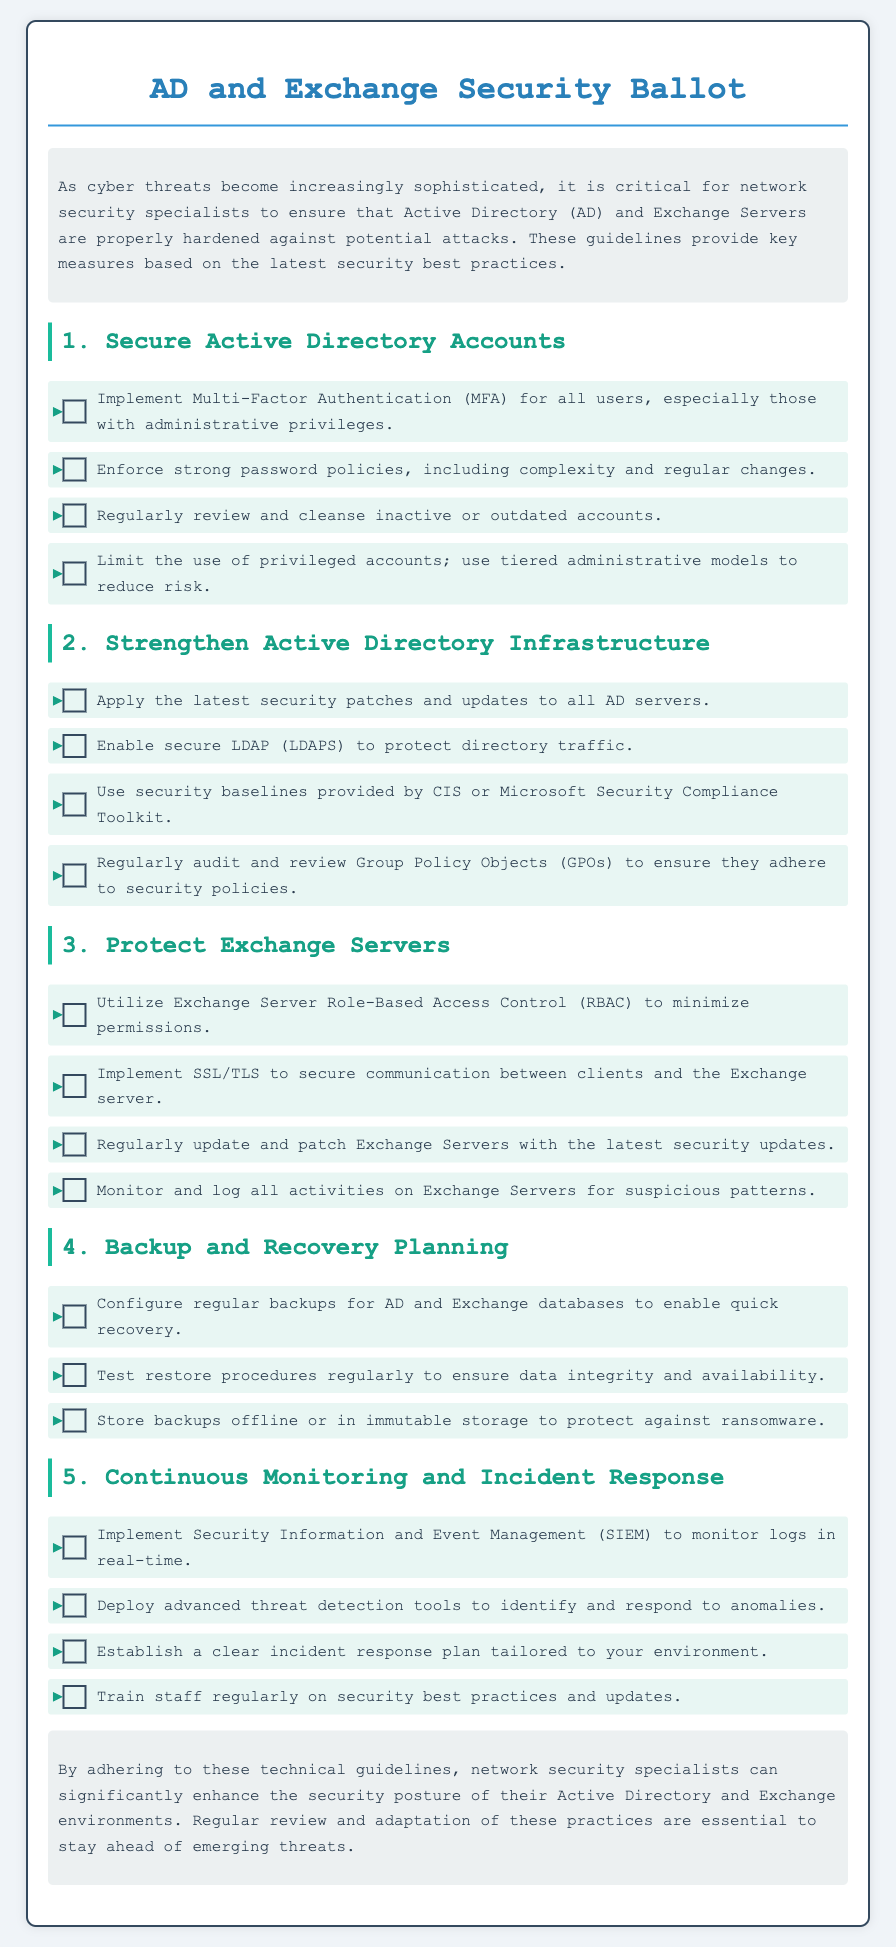What is the title of the document? The title of the document is specified at the top as "AD and Exchange Security Ballot."
Answer: AD and Exchange Security Ballot How many sections are there in the document? The document has 5 main sections, each related to securing Active Directory and Exchange.
Answer: 5 What is the first guideline for securing Active Directory accounts? The first guideline listed in the section is "Implement Multi-Factor Authentication (MFA) for all users, especially those with administrative privileges."
Answer: Implement Multi-Factor Authentication (MFA) What should be done with inactive or outdated accounts? The document states to "Regularly review and cleanse inactive or outdated accounts."
Answer: Regularly review and cleanse Which access control is recommended for Exchange Servers? It is recommended to "Utilize Exchange Server Role-Based Access Control (RBAC) to minimize permissions."
Answer: Role-Based Access Control (RBAC) What type of backup storage is suggested to protect against ransomware? The guideline suggests to "Store backups offline or in immutable storage to protect against ransomware."
Answer: Offline or immutable storage What management system should be implemented for real-time monitoring? The document recommends implementing "Security Information and Event Management (SIEM) to monitor logs in real-time."
Answer: Security Information and Event Management (SIEM) What is the conclusion regarding these guidelines? The document concludes that adherence to the guidelines significantly enhances security posture, and regular review is essential.
Answer: Enhance the security posture 